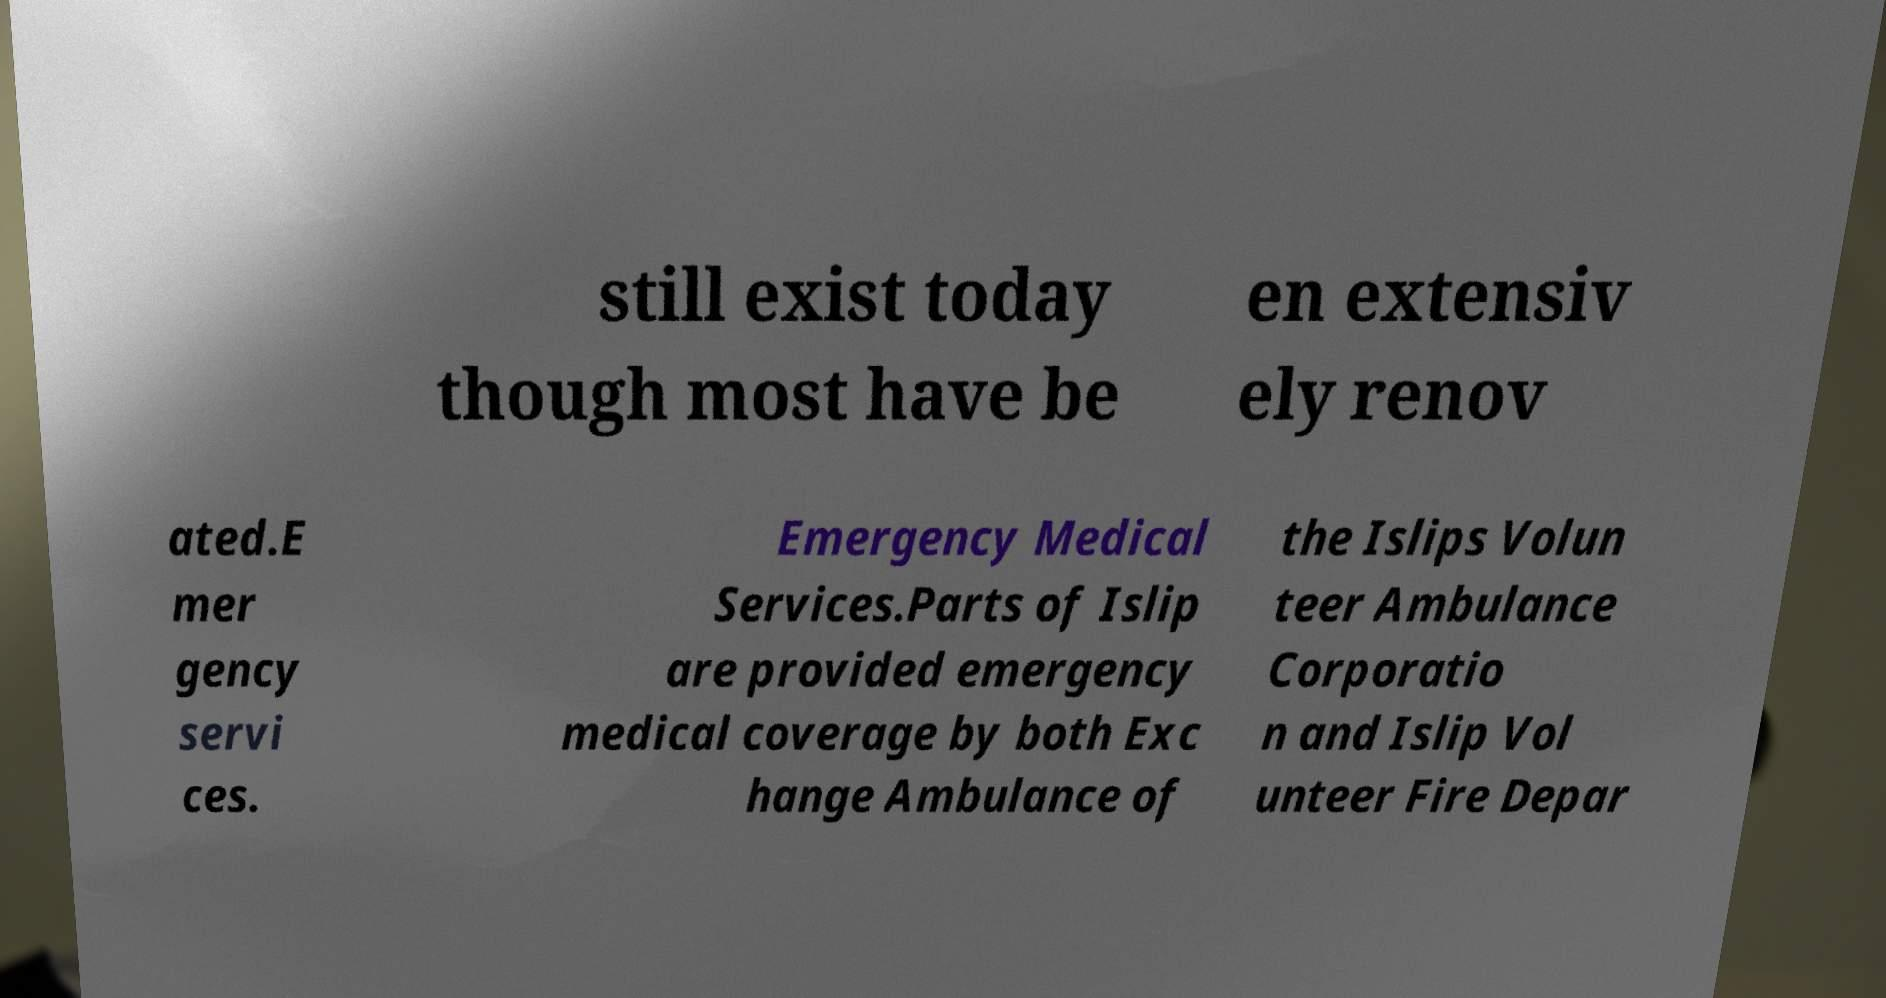I need the written content from this picture converted into text. Can you do that? still exist today though most have be en extensiv ely renov ated.E mer gency servi ces. Emergency Medical Services.Parts of Islip are provided emergency medical coverage by both Exc hange Ambulance of the Islips Volun teer Ambulance Corporatio n and Islip Vol unteer Fire Depar 